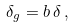<formula> <loc_0><loc_0><loc_500><loc_500>\delta _ { g } = b \, \delta \, ,</formula> 